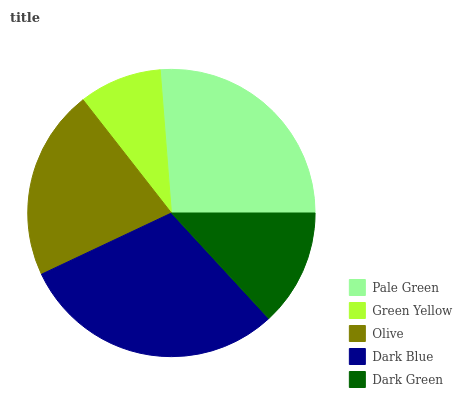Is Green Yellow the minimum?
Answer yes or no. Yes. Is Dark Blue the maximum?
Answer yes or no. Yes. Is Olive the minimum?
Answer yes or no. No. Is Olive the maximum?
Answer yes or no. No. Is Olive greater than Green Yellow?
Answer yes or no. Yes. Is Green Yellow less than Olive?
Answer yes or no. Yes. Is Green Yellow greater than Olive?
Answer yes or no. No. Is Olive less than Green Yellow?
Answer yes or no. No. Is Olive the high median?
Answer yes or no. Yes. Is Olive the low median?
Answer yes or no. Yes. Is Green Yellow the high median?
Answer yes or no. No. Is Dark Green the low median?
Answer yes or no. No. 